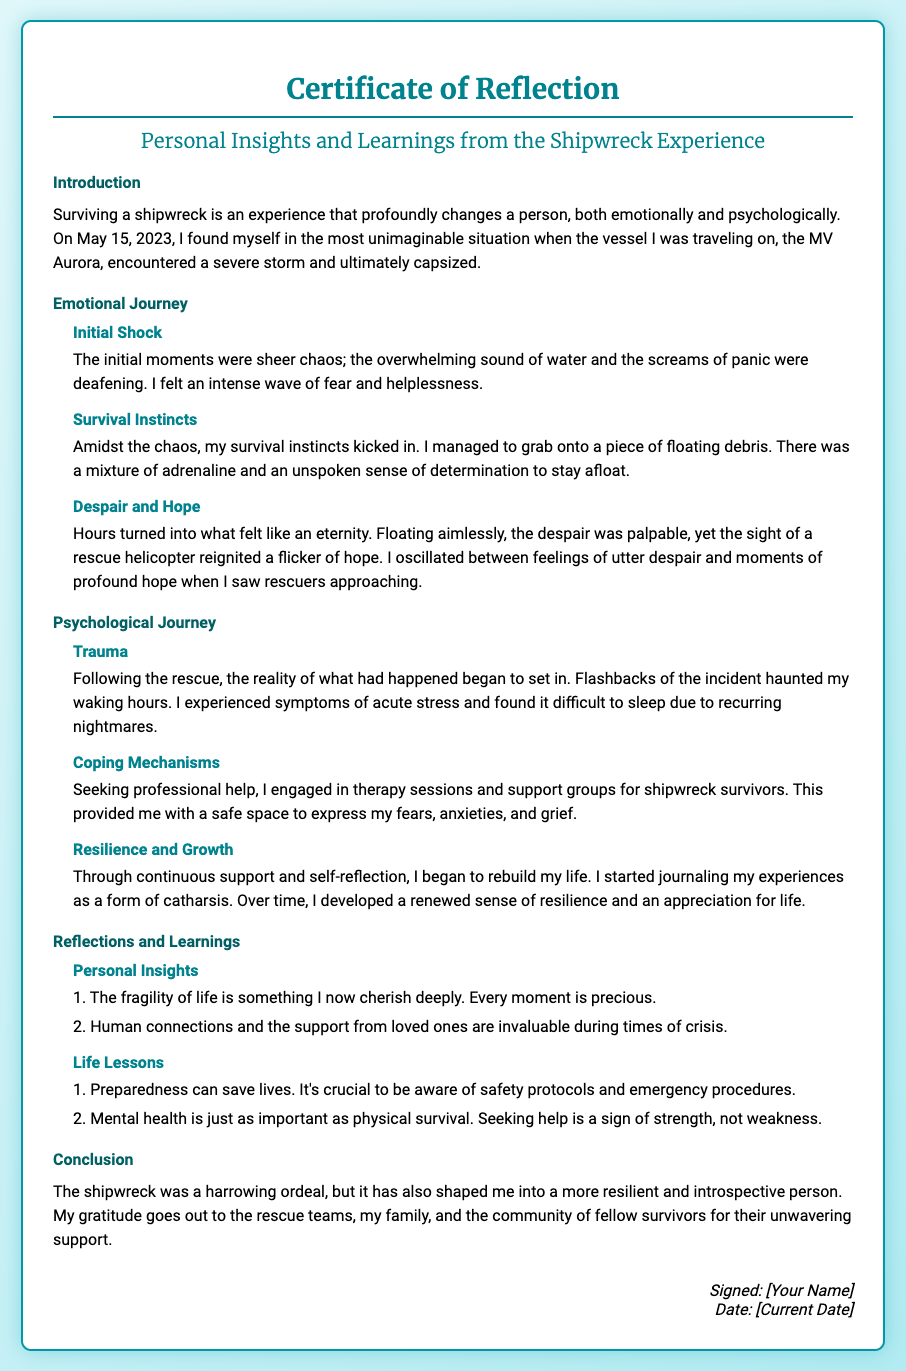what is the title of the certificate? The title is presented at the top of the document, indicating the nature of the content.
Answer: Certificate of Reflection what date did the shipwreck occur? The date is mentioned in the introduction section, providing context for the experience shared in the document.
Answer: May 15, 2023 what was the name of the vessel involved in the shipwreck? The name of the vessel is explicitly stated in the introduction, essential for understanding the event.
Answer: MV Aurora what emotion is described during the initial moments of the shipwreck? The document describes the experience during the initial moments, highlighting a specific feeling faced by the survivor.
Answer: Fear what coping mechanism did the survivor engage in after the rescue? The document outlines the actions taken by the individual post-rescue as a method to cope with their experience.
Answer: Therapy sessions which section discusses personal insights? This section is specifically focused on reflections and the lessons learned from the experience.
Answer: Reflections and Learnings how did the survivor describe their psychological trauma? The document details the nature of the psychological experience post-shipwreck, including specific symptoms faced.
Answer: Flashbacks what is a lesson learned about mental health? The document emphasizes a key lesson regarding the importance of mental health and seeking support.
Answer: Seeking help is a sign of strength who is acknowledged for their support in the conclusion? The conclusion expresses gratitude towards specific groups who assisted during and after the ordeal.
Answer: Rescue teams, family, and community 